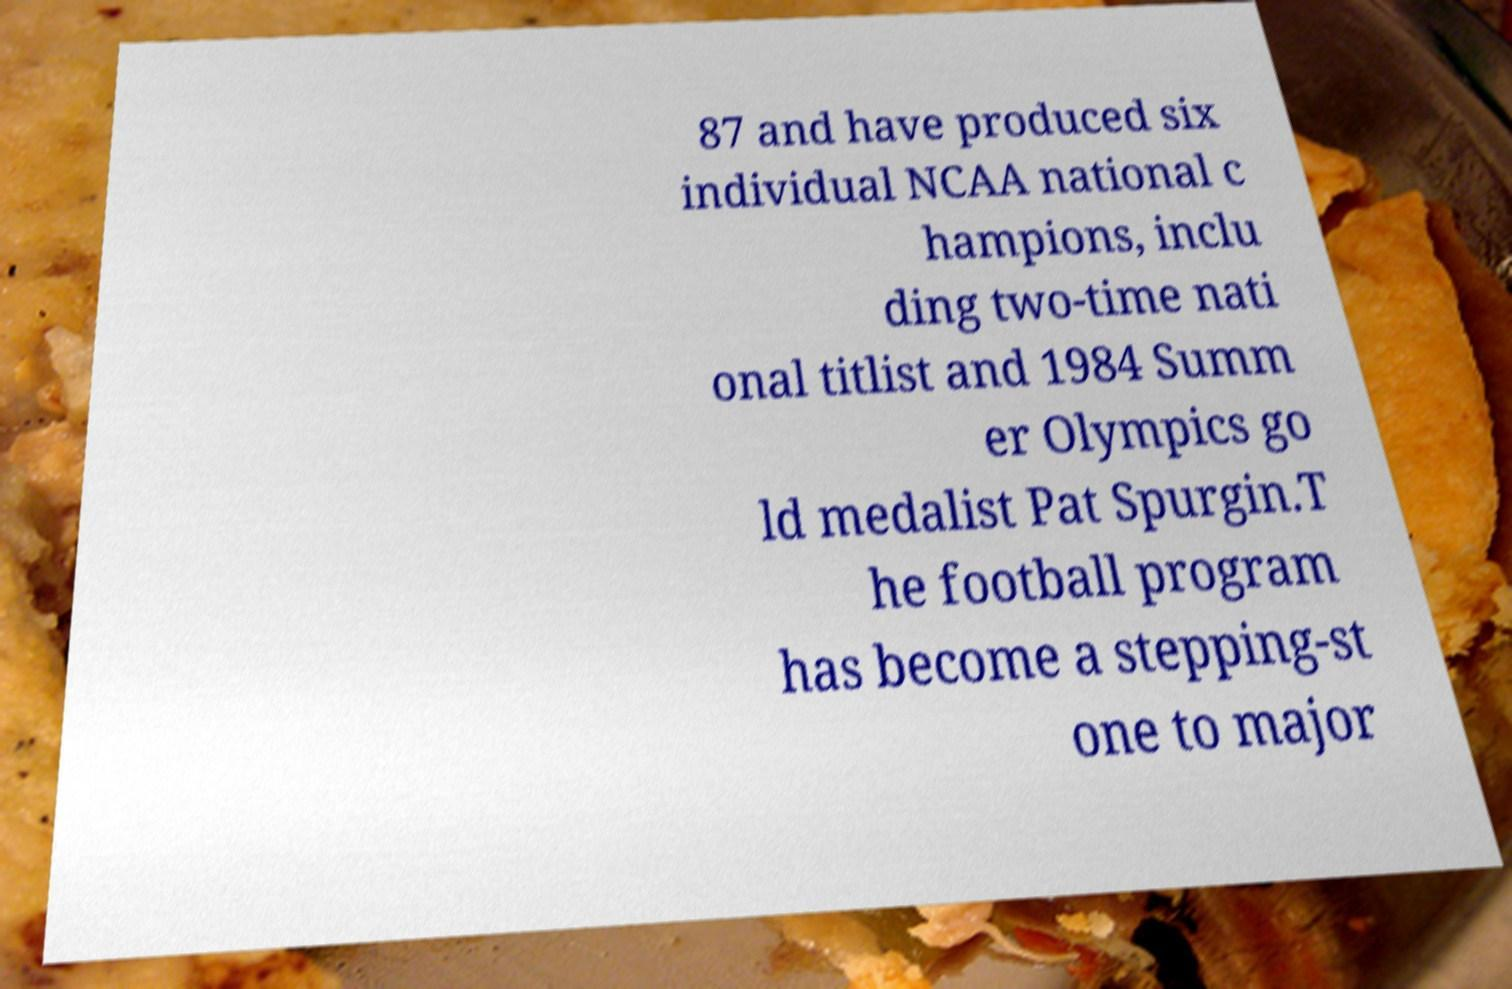Please identify and transcribe the text found in this image. 87 and have produced six individual NCAA national c hampions, inclu ding two-time nati onal titlist and 1984 Summ er Olympics go ld medalist Pat Spurgin.T he football program has become a stepping-st one to major 